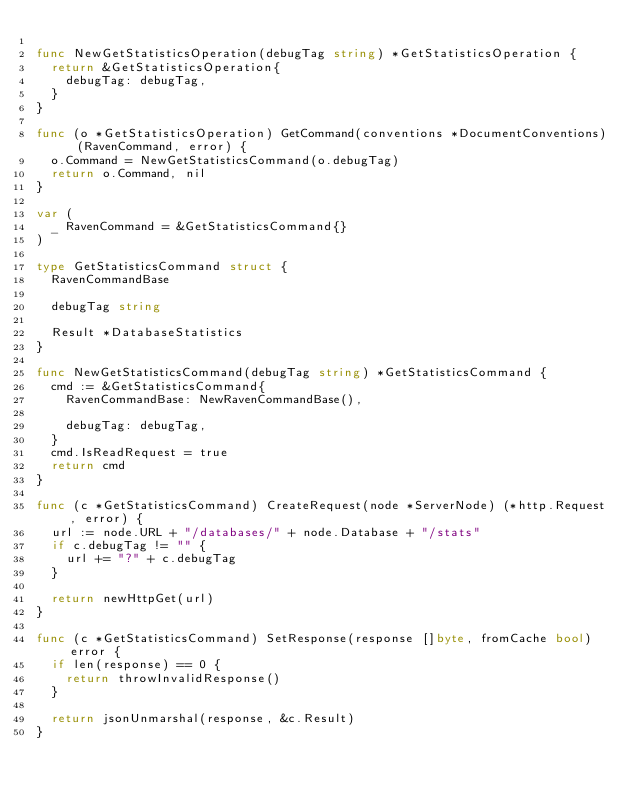Convert code to text. <code><loc_0><loc_0><loc_500><loc_500><_Go_>
func NewGetStatisticsOperation(debugTag string) *GetStatisticsOperation {
	return &GetStatisticsOperation{
		debugTag: debugTag,
	}
}

func (o *GetStatisticsOperation) GetCommand(conventions *DocumentConventions) (RavenCommand, error) {
	o.Command = NewGetStatisticsCommand(o.debugTag)
	return o.Command, nil
}

var (
	_ RavenCommand = &GetStatisticsCommand{}
)

type GetStatisticsCommand struct {
	RavenCommandBase

	debugTag string

	Result *DatabaseStatistics
}

func NewGetStatisticsCommand(debugTag string) *GetStatisticsCommand {
	cmd := &GetStatisticsCommand{
		RavenCommandBase: NewRavenCommandBase(),

		debugTag: debugTag,
	}
	cmd.IsReadRequest = true
	return cmd
}

func (c *GetStatisticsCommand) CreateRequest(node *ServerNode) (*http.Request, error) {
	url := node.URL + "/databases/" + node.Database + "/stats"
	if c.debugTag != "" {
		url += "?" + c.debugTag
	}

	return newHttpGet(url)
}

func (c *GetStatisticsCommand) SetResponse(response []byte, fromCache bool) error {
	if len(response) == 0 {
		return throwInvalidResponse()
	}

	return jsonUnmarshal(response, &c.Result)
}
</code> 